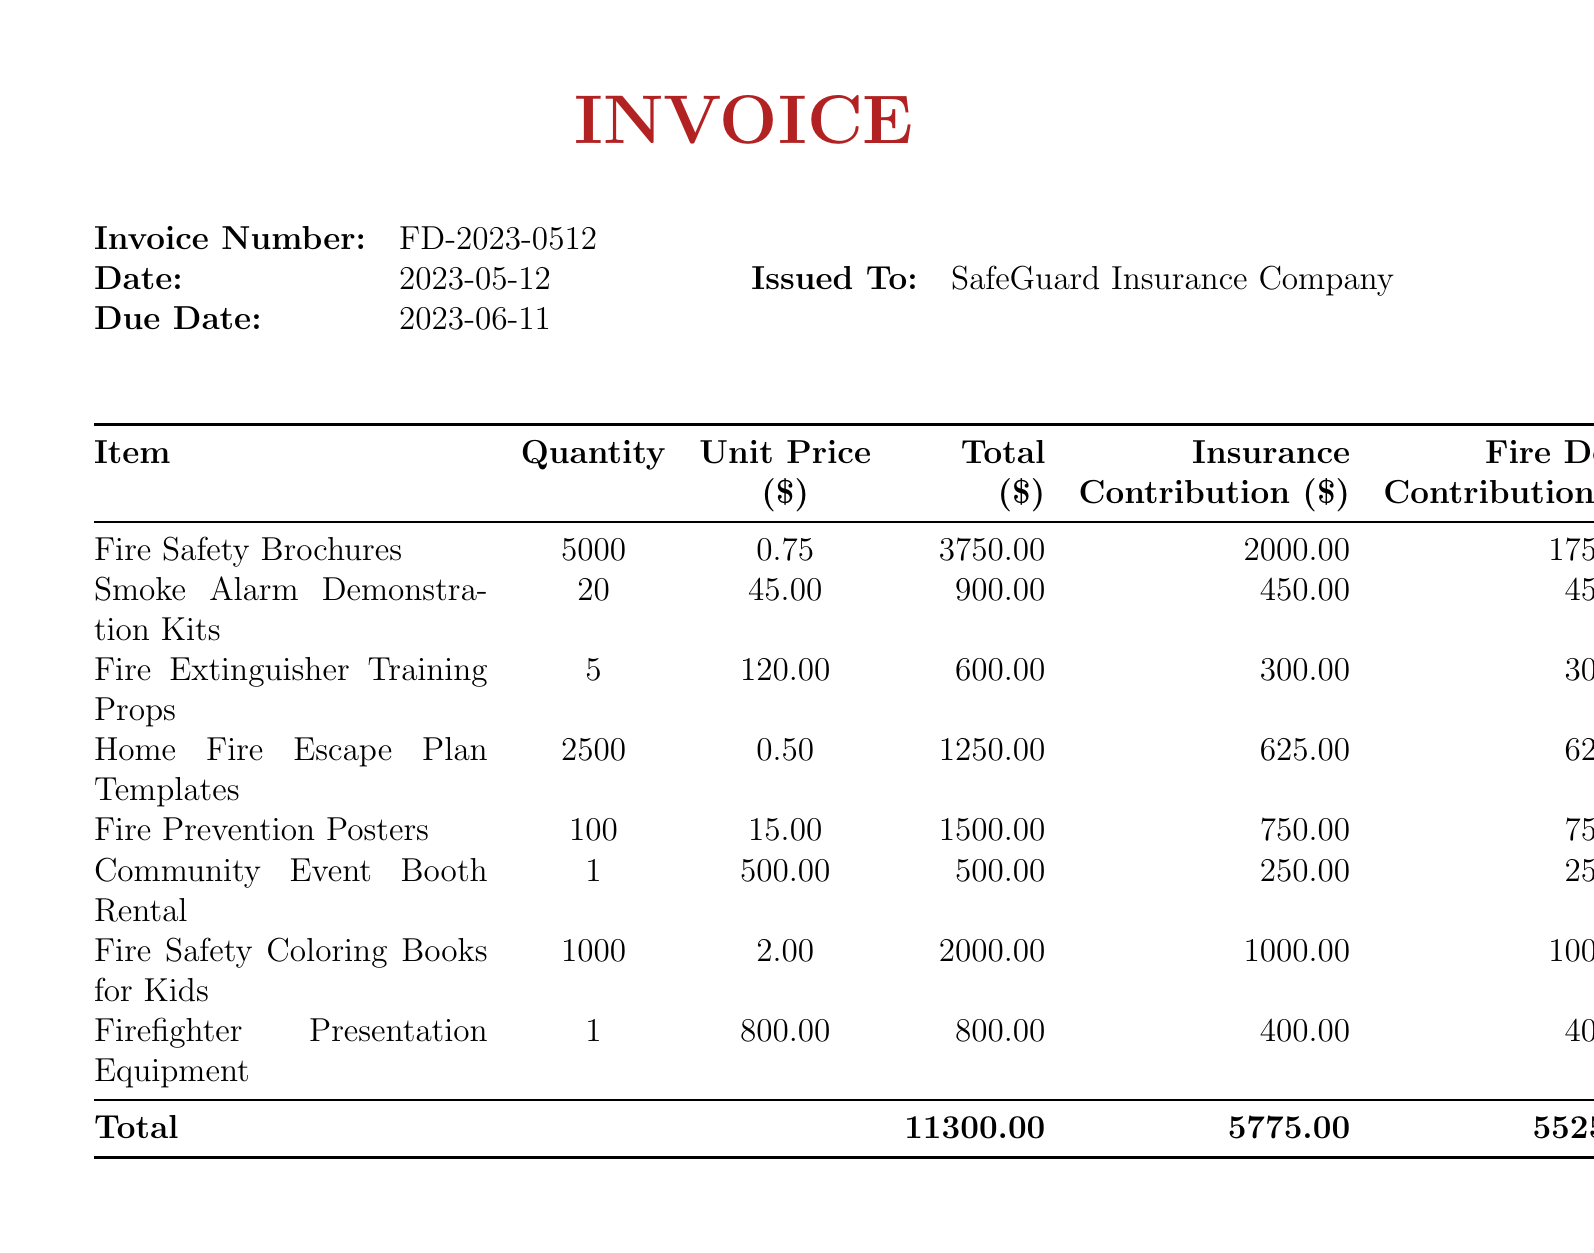What is the invoice number? The invoice number is specified at the top of the document as FD-2023-0512.
Answer: FD-2023-0512 What is the due date for the invoice? The due date is noted in the document as 2023-06-11.
Answer: 2023-06-11 How much did SafeGuard Insurance contribute for the Fire Safety Brochures? The insurance contribution for the Fire Safety Brochures is listed as 2000.00.
Answer: 2000.00 What is the total expense amount? The total expense is provided in the totals section as 11300.00.
Answer: 11300.00 How many Fire Safety Coloring Books for Kids were ordered? The quantity of Fire Safety Coloring Books ordered is stated as 1000.
Answer: 1000 What is the total insurance contribution across all items? The total insurance contribution is given as 5775.00.
Answer: 5775.00 What percentage of the total expense does the fire department contribute? The fire department's contribution is 5525.00 out of a total of 11300.00, which needs calculation: (5525.00 / 11300.00) * 100 = approximately 48.88%.
Answer: 48.88% What is required to pay the invoice? The document specifies payment instructions with a recipient name and bank details.
Answer: Payable to Central City Fire Department What additional fire prevention tip is included in the notes? One of the additional fire prevention tips shared is the importance of keeping fire hydrants clear and accessible.
Answer: Importance of keeping fire hydrants clear and accessible 